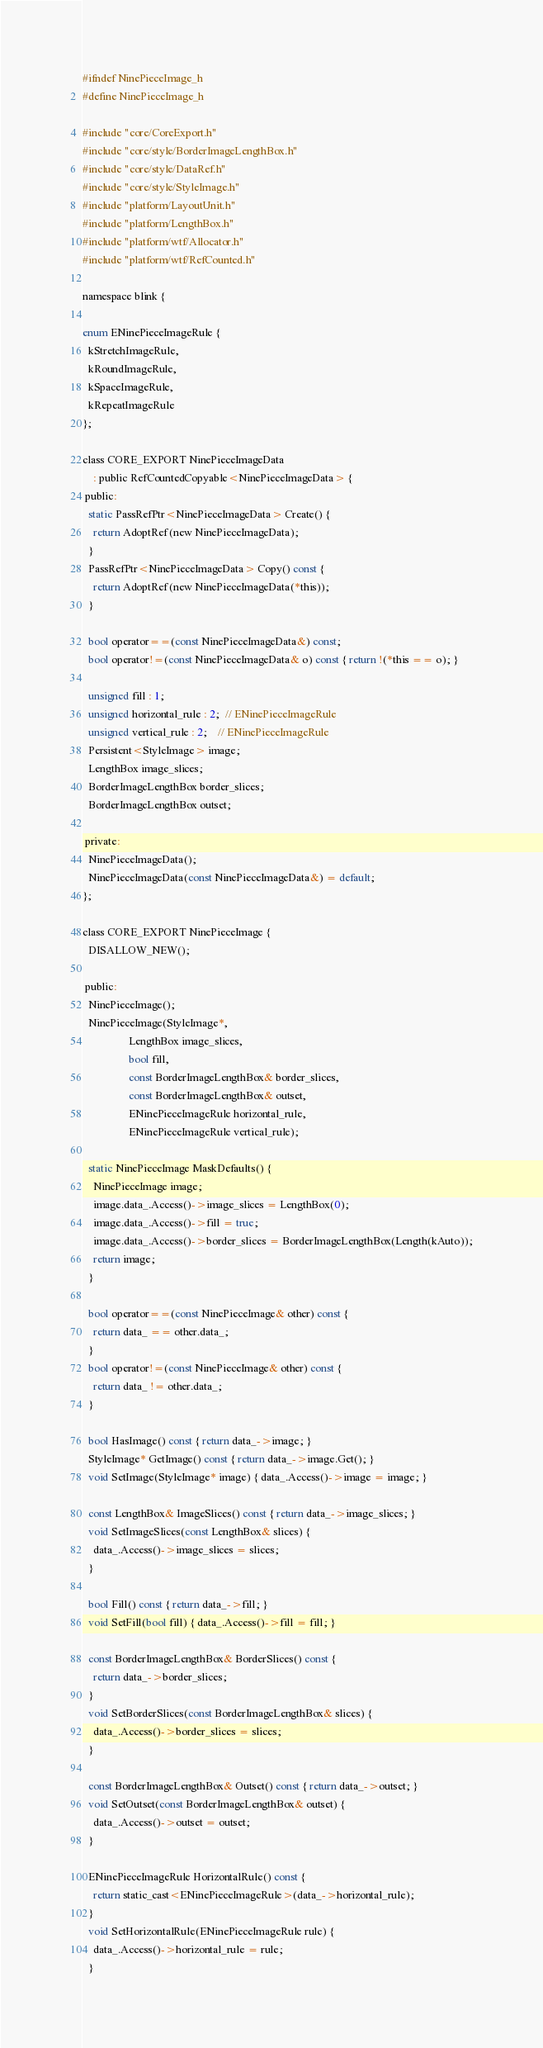<code> <loc_0><loc_0><loc_500><loc_500><_C_>
#ifndef NinePieceImage_h
#define NinePieceImage_h

#include "core/CoreExport.h"
#include "core/style/BorderImageLengthBox.h"
#include "core/style/DataRef.h"
#include "core/style/StyleImage.h"
#include "platform/LayoutUnit.h"
#include "platform/LengthBox.h"
#include "platform/wtf/Allocator.h"
#include "platform/wtf/RefCounted.h"

namespace blink {

enum ENinePieceImageRule {
  kStretchImageRule,
  kRoundImageRule,
  kSpaceImageRule,
  kRepeatImageRule
};

class CORE_EXPORT NinePieceImageData
    : public RefCountedCopyable<NinePieceImageData> {
 public:
  static PassRefPtr<NinePieceImageData> Create() {
    return AdoptRef(new NinePieceImageData);
  }
  PassRefPtr<NinePieceImageData> Copy() const {
    return AdoptRef(new NinePieceImageData(*this));
  }

  bool operator==(const NinePieceImageData&) const;
  bool operator!=(const NinePieceImageData& o) const { return !(*this == o); }

  unsigned fill : 1;
  unsigned horizontal_rule : 2;  // ENinePieceImageRule
  unsigned vertical_rule : 2;    // ENinePieceImageRule
  Persistent<StyleImage> image;
  LengthBox image_slices;
  BorderImageLengthBox border_slices;
  BorderImageLengthBox outset;

 private:
  NinePieceImageData();
  NinePieceImageData(const NinePieceImageData&) = default;
};

class CORE_EXPORT NinePieceImage {
  DISALLOW_NEW();

 public:
  NinePieceImage();
  NinePieceImage(StyleImage*,
                 LengthBox image_slices,
                 bool fill,
                 const BorderImageLengthBox& border_slices,
                 const BorderImageLengthBox& outset,
                 ENinePieceImageRule horizontal_rule,
                 ENinePieceImageRule vertical_rule);

  static NinePieceImage MaskDefaults() {
    NinePieceImage image;
    image.data_.Access()->image_slices = LengthBox(0);
    image.data_.Access()->fill = true;
    image.data_.Access()->border_slices = BorderImageLengthBox(Length(kAuto));
    return image;
  }

  bool operator==(const NinePieceImage& other) const {
    return data_ == other.data_;
  }
  bool operator!=(const NinePieceImage& other) const {
    return data_ != other.data_;
  }

  bool HasImage() const { return data_->image; }
  StyleImage* GetImage() const { return data_->image.Get(); }
  void SetImage(StyleImage* image) { data_.Access()->image = image; }

  const LengthBox& ImageSlices() const { return data_->image_slices; }
  void SetImageSlices(const LengthBox& slices) {
    data_.Access()->image_slices = slices;
  }

  bool Fill() const { return data_->fill; }
  void SetFill(bool fill) { data_.Access()->fill = fill; }

  const BorderImageLengthBox& BorderSlices() const {
    return data_->border_slices;
  }
  void SetBorderSlices(const BorderImageLengthBox& slices) {
    data_.Access()->border_slices = slices;
  }

  const BorderImageLengthBox& Outset() const { return data_->outset; }
  void SetOutset(const BorderImageLengthBox& outset) {
    data_.Access()->outset = outset;
  }

  ENinePieceImageRule HorizontalRule() const {
    return static_cast<ENinePieceImageRule>(data_->horizontal_rule);
  }
  void SetHorizontalRule(ENinePieceImageRule rule) {
    data_.Access()->horizontal_rule = rule;
  }
</code> 